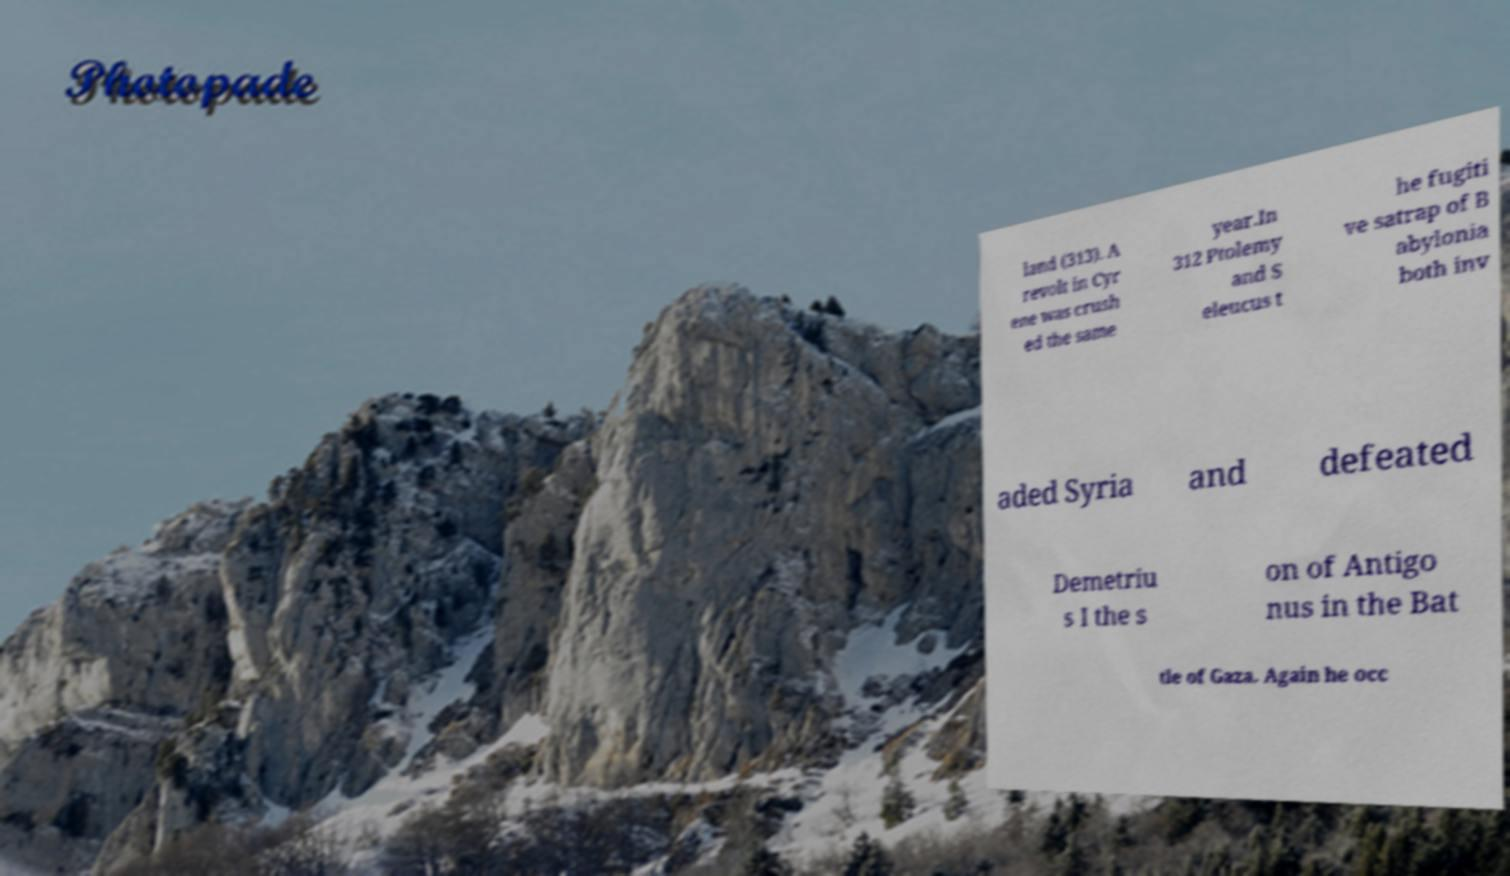I need the written content from this picture converted into text. Can you do that? land (313). A revolt in Cyr ene was crush ed the same year.In 312 Ptolemy and S eleucus t he fugiti ve satrap of B abylonia both inv aded Syria and defeated Demetriu s I the s on of Antigo nus in the Bat tle of Gaza. Again he occ 